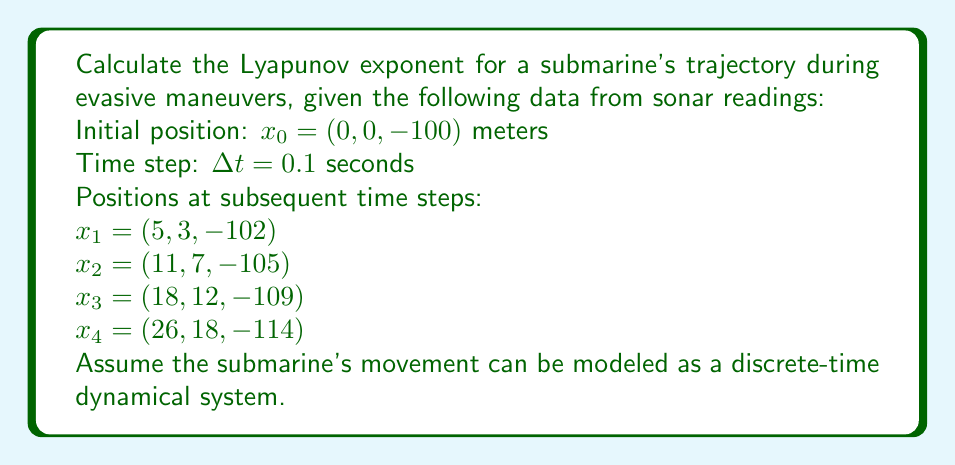Teach me how to tackle this problem. To calculate the Lyapunov exponent for the submarine's trajectory, we'll follow these steps:

1) The Lyapunov exponent $\lambda$ for a discrete-time system is given by:

   $$\lambda = \lim_{n \to \infty} \frac{1}{n} \sum_{i=0}^{n-1} \ln \left(\frac{||x_{i+1} - x_i||}{||x_1 - x_0||}\right)$$

2) We have 5 position vectors, so we can calculate 4 differences:

   $||x_1 - x_0|| = \sqrt{5^2 + 3^2 + (-2)^2} = \sqrt{38} \approx 6.16$
   $||x_2 - x_1|| = \sqrt{6^2 + 4^2 + (-3)^2} = \sqrt{61} \approx 7.81$
   $||x_3 - x_2|| = \sqrt{7^2 + 5^2 + (-4)^2} = \sqrt{90} \approx 9.49$
   $||x_4 - x_3|| = \sqrt{8^2 + 6^2 + (-5)^2} = \sqrt{125} \approx 11.18$

3) Now we calculate the ratios and their natural logarithms:

   $\ln(\frac{||x_2 - x_1||}{||x_1 - x_0||}) = \ln(\frac{7.81}{6.16}) \approx 0.237$
   $\ln(\frac{||x_3 - x_2||}{||x_1 - x_0||}) = \ln(\frac{9.49}{6.16}) \approx 0.432$
   $\ln(\frac{||x_4 - x_3||}{||x_1 - x_0||}) = \ln(\frac{11.18}{6.16}) \approx 0.597$

4) We sum these values and divide by the number of terms (3):

   $\lambda \approx \frac{1}{3}(0.237 + 0.432 + 0.597) \approx 0.422$

5) To convert this to a rate per second, we divide by the time step:

   $\lambda_{per second} = \frac{0.422}{0.1} = 4.22$

This positive Lyapunov exponent indicates that nearby trajectories are diverging exponentially, which is characteristic of chaotic behavior during evasive maneuvers.
Answer: $4.22$ s$^{-1}$ 